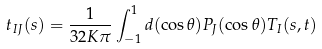<formula> <loc_0><loc_0><loc_500><loc_500>t _ { I J } ( s ) = \frac { 1 } { 3 2 K \pi } \int _ { - 1 } ^ { 1 } d ( \cos \theta ) P _ { J } ( \cos \theta ) T _ { I } ( s , t )</formula> 